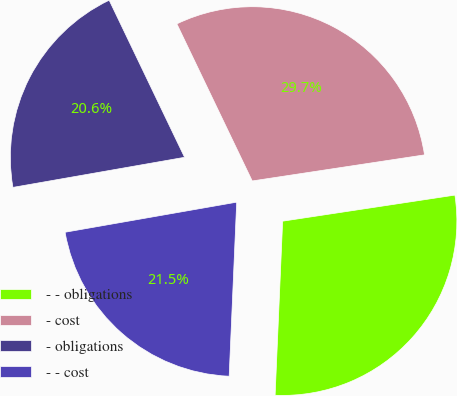Convert chart. <chart><loc_0><loc_0><loc_500><loc_500><pie_chart><fcel>- - obligations<fcel>- cost<fcel>- obligations<fcel>- - cost<nl><fcel>28.08%<fcel>29.73%<fcel>20.64%<fcel>21.55%<nl></chart> 